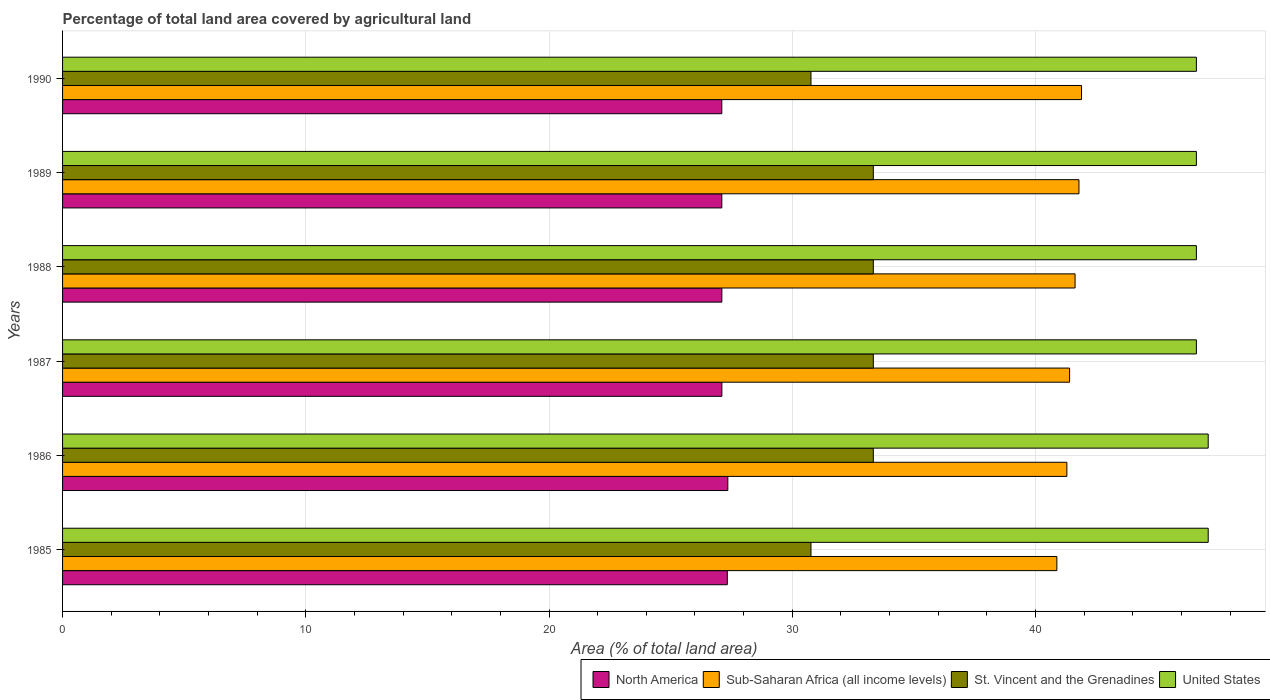How many different coloured bars are there?
Ensure brevity in your answer.  4. Are the number of bars per tick equal to the number of legend labels?
Offer a terse response. Yes. How many bars are there on the 4th tick from the top?
Keep it short and to the point. 4. How many bars are there on the 5th tick from the bottom?
Keep it short and to the point. 4. What is the percentage of agricultural land in United States in 1989?
Your answer should be very brief. 46.62. Across all years, what is the maximum percentage of agricultural land in St. Vincent and the Grenadines?
Provide a succinct answer. 33.33. Across all years, what is the minimum percentage of agricultural land in St. Vincent and the Grenadines?
Your response must be concise. 30.77. In which year was the percentage of agricultural land in North America maximum?
Make the answer very short. 1986. What is the total percentage of agricultural land in United States in the graph?
Your response must be concise. 280.66. What is the difference between the percentage of agricultural land in St. Vincent and the Grenadines in 1985 and that in 1987?
Your answer should be compact. -2.56. What is the difference between the percentage of agricultural land in United States in 1990 and the percentage of agricultural land in North America in 1987?
Your response must be concise. 19.51. What is the average percentage of agricultural land in United States per year?
Ensure brevity in your answer.  46.78. In the year 1989, what is the difference between the percentage of agricultural land in St. Vincent and the Grenadines and percentage of agricultural land in United States?
Keep it short and to the point. -13.28. What is the ratio of the percentage of agricultural land in North America in 1985 to that in 1986?
Your answer should be compact. 1. Is the difference between the percentage of agricultural land in St. Vincent and the Grenadines in 1988 and 1989 greater than the difference between the percentage of agricultural land in United States in 1988 and 1989?
Offer a very short reply. No. What is the difference between the highest and the second highest percentage of agricultural land in St. Vincent and the Grenadines?
Offer a terse response. 0. What is the difference between the highest and the lowest percentage of agricultural land in Sub-Saharan Africa (all income levels)?
Offer a very short reply. 1.01. Is the sum of the percentage of agricultural land in North America in 1989 and 1990 greater than the maximum percentage of agricultural land in St. Vincent and the Grenadines across all years?
Make the answer very short. Yes. What does the 1st bar from the top in 1988 represents?
Your answer should be compact. United States. Is it the case that in every year, the sum of the percentage of agricultural land in Sub-Saharan Africa (all income levels) and percentage of agricultural land in North America is greater than the percentage of agricultural land in St. Vincent and the Grenadines?
Ensure brevity in your answer.  Yes. How many bars are there?
Keep it short and to the point. 24. Are all the bars in the graph horizontal?
Keep it short and to the point. Yes. How many years are there in the graph?
Your answer should be compact. 6. What is the difference between two consecutive major ticks on the X-axis?
Offer a terse response. 10. Are the values on the major ticks of X-axis written in scientific E-notation?
Your response must be concise. No. How many legend labels are there?
Ensure brevity in your answer.  4. How are the legend labels stacked?
Your answer should be very brief. Horizontal. What is the title of the graph?
Keep it short and to the point. Percentage of total land area covered by agricultural land. Does "Maldives" appear as one of the legend labels in the graph?
Offer a very short reply. No. What is the label or title of the X-axis?
Make the answer very short. Area (% of total land area). What is the label or title of the Y-axis?
Your answer should be compact. Years. What is the Area (% of total land area) in North America in 1985?
Your answer should be very brief. 27.33. What is the Area (% of total land area) in Sub-Saharan Africa (all income levels) in 1985?
Offer a very short reply. 40.88. What is the Area (% of total land area) of St. Vincent and the Grenadines in 1985?
Offer a very short reply. 30.77. What is the Area (% of total land area) in United States in 1985?
Provide a short and direct response. 47.1. What is the Area (% of total land area) of North America in 1986?
Offer a very short reply. 27.35. What is the Area (% of total land area) in Sub-Saharan Africa (all income levels) in 1986?
Your response must be concise. 41.29. What is the Area (% of total land area) of St. Vincent and the Grenadines in 1986?
Your response must be concise. 33.33. What is the Area (% of total land area) of United States in 1986?
Your answer should be compact. 47.1. What is the Area (% of total land area) in North America in 1987?
Your answer should be compact. 27.11. What is the Area (% of total land area) in Sub-Saharan Africa (all income levels) in 1987?
Offer a very short reply. 41.4. What is the Area (% of total land area) of St. Vincent and the Grenadines in 1987?
Provide a succinct answer. 33.33. What is the Area (% of total land area) in United States in 1987?
Provide a succinct answer. 46.62. What is the Area (% of total land area) in North America in 1988?
Your answer should be very brief. 27.11. What is the Area (% of total land area) in Sub-Saharan Africa (all income levels) in 1988?
Your answer should be compact. 41.63. What is the Area (% of total land area) in St. Vincent and the Grenadines in 1988?
Ensure brevity in your answer.  33.33. What is the Area (% of total land area) of United States in 1988?
Keep it short and to the point. 46.62. What is the Area (% of total land area) in North America in 1989?
Your response must be concise. 27.1. What is the Area (% of total land area) of Sub-Saharan Africa (all income levels) in 1989?
Provide a succinct answer. 41.79. What is the Area (% of total land area) in St. Vincent and the Grenadines in 1989?
Give a very brief answer. 33.33. What is the Area (% of total land area) in United States in 1989?
Offer a terse response. 46.62. What is the Area (% of total land area) of North America in 1990?
Ensure brevity in your answer.  27.1. What is the Area (% of total land area) of Sub-Saharan Africa (all income levels) in 1990?
Keep it short and to the point. 41.89. What is the Area (% of total land area) of St. Vincent and the Grenadines in 1990?
Give a very brief answer. 30.77. What is the Area (% of total land area) in United States in 1990?
Offer a terse response. 46.62. Across all years, what is the maximum Area (% of total land area) of North America?
Make the answer very short. 27.35. Across all years, what is the maximum Area (% of total land area) in Sub-Saharan Africa (all income levels)?
Give a very brief answer. 41.89. Across all years, what is the maximum Area (% of total land area) in St. Vincent and the Grenadines?
Provide a short and direct response. 33.33. Across all years, what is the maximum Area (% of total land area) of United States?
Offer a terse response. 47.1. Across all years, what is the minimum Area (% of total land area) of North America?
Your answer should be very brief. 27.1. Across all years, what is the minimum Area (% of total land area) of Sub-Saharan Africa (all income levels)?
Keep it short and to the point. 40.88. Across all years, what is the minimum Area (% of total land area) of St. Vincent and the Grenadines?
Your answer should be compact. 30.77. Across all years, what is the minimum Area (% of total land area) of United States?
Your answer should be very brief. 46.62. What is the total Area (% of total land area) in North America in the graph?
Your answer should be very brief. 163.1. What is the total Area (% of total land area) in Sub-Saharan Africa (all income levels) in the graph?
Give a very brief answer. 248.88. What is the total Area (% of total land area) of St. Vincent and the Grenadines in the graph?
Keep it short and to the point. 194.87. What is the total Area (% of total land area) of United States in the graph?
Keep it short and to the point. 280.66. What is the difference between the Area (% of total land area) in North America in 1985 and that in 1986?
Your answer should be very brief. -0.02. What is the difference between the Area (% of total land area) in Sub-Saharan Africa (all income levels) in 1985 and that in 1986?
Your answer should be compact. -0.41. What is the difference between the Area (% of total land area) of St. Vincent and the Grenadines in 1985 and that in 1986?
Offer a very short reply. -2.56. What is the difference between the Area (% of total land area) of North America in 1985 and that in 1987?
Offer a terse response. 0.22. What is the difference between the Area (% of total land area) of Sub-Saharan Africa (all income levels) in 1985 and that in 1987?
Your answer should be very brief. -0.52. What is the difference between the Area (% of total land area) of St. Vincent and the Grenadines in 1985 and that in 1987?
Make the answer very short. -2.56. What is the difference between the Area (% of total land area) in United States in 1985 and that in 1987?
Provide a short and direct response. 0.49. What is the difference between the Area (% of total land area) of North America in 1985 and that in 1988?
Your answer should be very brief. 0.22. What is the difference between the Area (% of total land area) in Sub-Saharan Africa (all income levels) in 1985 and that in 1988?
Provide a succinct answer. -0.75. What is the difference between the Area (% of total land area) of St. Vincent and the Grenadines in 1985 and that in 1988?
Ensure brevity in your answer.  -2.56. What is the difference between the Area (% of total land area) of United States in 1985 and that in 1988?
Offer a terse response. 0.49. What is the difference between the Area (% of total land area) in North America in 1985 and that in 1989?
Your response must be concise. 0.23. What is the difference between the Area (% of total land area) of Sub-Saharan Africa (all income levels) in 1985 and that in 1989?
Offer a terse response. -0.91. What is the difference between the Area (% of total land area) in St. Vincent and the Grenadines in 1985 and that in 1989?
Offer a very short reply. -2.56. What is the difference between the Area (% of total land area) in United States in 1985 and that in 1989?
Make the answer very short. 0.49. What is the difference between the Area (% of total land area) in North America in 1985 and that in 1990?
Ensure brevity in your answer.  0.23. What is the difference between the Area (% of total land area) of Sub-Saharan Africa (all income levels) in 1985 and that in 1990?
Ensure brevity in your answer.  -1.01. What is the difference between the Area (% of total land area) of St. Vincent and the Grenadines in 1985 and that in 1990?
Offer a very short reply. 0. What is the difference between the Area (% of total land area) of United States in 1985 and that in 1990?
Your response must be concise. 0.49. What is the difference between the Area (% of total land area) of North America in 1986 and that in 1987?
Your answer should be very brief. 0.24. What is the difference between the Area (% of total land area) of Sub-Saharan Africa (all income levels) in 1986 and that in 1987?
Provide a succinct answer. -0.11. What is the difference between the Area (% of total land area) in United States in 1986 and that in 1987?
Give a very brief answer. 0.49. What is the difference between the Area (% of total land area) of North America in 1986 and that in 1988?
Make the answer very short. 0.25. What is the difference between the Area (% of total land area) of Sub-Saharan Africa (all income levels) in 1986 and that in 1988?
Ensure brevity in your answer.  -0.34. What is the difference between the Area (% of total land area) in St. Vincent and the Grenadines in 1986 and that in 1988?
Your answer should be compact. 0. What is the difference between the Area (% of total land area) of United States in 1986 and that in 1988?
Keep it short and to the point. 0.49. What is the difference between the Area (% of total land area) in North America in 1986 and that in 1989?
Offer a terse response. 0.25. What is the difference between the Area (% of total land area) in Sub-Saharan Africa (all income levels) in 1986 and that in 1989?
Provide a short and direct response. -0.5. What is the difference between the Area (% of total land area) of United States in 1986 and that in 1989?
Provide a succinct answer. 0.49. What is the difference between the Area (% of total land area) of North America in 1986 and that in 1990?
Offer a terse response. 0.25. What is the difference between the Area (% of total land area) in Sub-Saharan Africa (all income levels) in 1986 and that in 1990?
Offer a very short reply. -0.6. What is the difference between the Area (% of total land area) of St. Vincent and the Grenadines in 1986 and that in 1990?
Ensure brevity in your answer.  2.56. What is the difference between the Area (% of total land area) in United States in 1986 and that in 1990?
Make the answer very short. 0.49. What is the difference between the Area (% of total land area) of North America in 1987 and that in 1988?
Your response must be concise. 0. What is the difference between the Area (% of total land area) in Sub-Saharan Africa (all income levels) in 1987 and that in 1988?
Provide a succinct answer. -0.22. What is the difference between the Area (% of total land area) of St. Vincent and the Grenadines in 1987 and that in 1988?
Give a very brief answer. 0. What is the difference between the Area (% of total land area) in United States in 1987 and that in 1988?
Your answer should be very brief. 0. What is the difference between the Area (% of total land area) of North America in 1987 and that in 1989?
Give a very brief answer. 0. What is the difference between the Area (% of total land area) of Sub-Saharan Africa (all income levels) in 1987 and that in 1989?
Your answer should be compact. -0.38. What is the difference between the Area (% of total land area) in St. Vincent and the Grenadines in 1987 and that in 1989?
Ensure brevity in your answer.  0. What is the difference between the Area (% of total land area) in North America in 1987 and that in 1990?
Give a very brief answer. 0. What is the difference between the Area (% of total land area) of Sub-Saharan Africa (all income levels) in 1987 and that in 1990?
Ensure brevity in your answer.  -0.49. What is the difference between the Area (% of total land area) in St. Vincent and the Grenadines in 1987 and that in 1990?
Make the answer very short. 2.56. What is the difference between the Area (% of total land area) in United States in 1987 and that in 1990?
Your response must be concise. 0. What is the difference between the Area (% of total land area) in North America in 1988 and that in 1989?
Your response must be concise. 0. What is the difference between the Area (% of total land area) of Sub-Saharan Africa (all income levels) in 1988 and that in 1989?
Keep it short and to the point. -0.16. What is the difference between the Area (% of total land area) in St. Vincent and the Grenadines in 1988 and that in 1989?
Keep it short and to the point. 0. What is the difference between the Area (% of total land area) of United States in 1988 and that in 1989?
Provide a short and direct response. 0. What is the difference between the Area (% of total land area) in North America in 1988 and that in 1990?
Ensure brevity in your answer.  0. What is the difference between the Area (% of total land area) of Sub-Saharan Africa (all income levels) in 1988 and that in 1990?
Give a very brief answer. -0.27. What is the difference between the Area (% of total land area) of St. Vincent and the Grenadines in 1988 and that in 1990?
Give a very brief answer. 2.56. What is the difference between the Area (% of total land area) in United States in 1988 and that in 1990?
Your answer should be very brief. 0. What is the difference between the Area (% of total land area) of North America in 1989 and that in 1990?
Provide a succinct answer. 0. What is the difference between the Area (% of total land area) of Sub-Saharan Africa (all income levels) in 1989 and that in 1990?
Ensure brevity in your answer.  -0.11. What is the difference between the Area (% of total land area) in St. Vincent and the Grenadines in 1989 and that in 1990?
Give a very brief answer. 2.56. What is the difference between the Area (% of total land area) in United States in 1989 and that in 1990?
Provide a short and direct response. 0. What is the difference between the Area (% of total land area) of North America in 1985 and the Area (% of total land area) of Sub-Saharan Africa (all income levels) in 1986?
Provide a succinct answer. -13.96. What is the difference between the Area (% of total land area) of North America in 1985 and the Area (% of total land area) of St. Vincent and the Grenadines in 1986?
Offer a very short reply. -6. What is the difference between the Area (% of total land area) of North America in 1985 and the Area (% of total land area) of United States in 1986?
Your answer should be compact. -19.77. What is the difference between the Area (% of total land area) of Sub-Saharan Africa (all income levels) in 1985 and the Area (% of total land area) of St. Vincent and the Grenadines in 1986?
Ensure brevity in your answer.  7.55. What is the difference between the Area (% of total land area) in Sub-Saharan Africa (all income levels) in 1985 and the Area (% of total land area) in United States in 1986?
Your response must be concise. -6.22. What is the difference between the Area (% of total land area) in St. Vincent and the Grenadines in 1985 and the Area (% of total land area) in United States in 1986?
Your response must be concise. -16.33. What is the difference between the Area (% of total land area) in North America in 1985 and the Area (% of total land area) in Sub-Saharan Africa (all income levels) in 1987?
Give a very brief answer. -14.07. What is the difference between the Area (% of total land area) in North America in 1985 and the Area (% of total land area) in St. Vincent and the Grenadines in 1987?
Keep it short and to the point. -6. What is the difference between the Area (% of total land area) in North America in 1985 and the Area (% of total land area) in United States in 1987?
Your answer should be compact. -19.29. What is the difference between the Area (% of total land area) in Sub-Saharan Africa (all income levels) in 1985 and the Area (% of total land area) in St. Vincent and the Grenadines in 1987?
Provide a succinct answer. 7.55. What is the difference between the Area (% of total land area) in Sub-Saharan Africa (all income levels) in 1985 and the Area (% of total land area) in United States in 1987?
Your answer should be very brief. -5.74. What is the difference between the Area (% of total land area) in St. Vincent and the Grenadines in 1985 and the Area (% of total land area) in United States in 1987?
Give a very brief answer. -15.85. What is the difference between the Area (% of total land area) of North America in 1985 and the Area (% of total land area) of Sub-Saharan Africa (all income levels) in 1988?
Your response must be concise. -14.3. What is the difference between the Area (% of total land area) of North America in 1985 and the Area (% of total land area) of St. Vincent and the Grenadines in 1988?
Ensure brevity in your answer.  -6. What is the difference between the Area (% of total land area) in North America in 1985 and the Area (% of total land area) in United States in 1988?
Your answer should be compact. -19.29. What is the difference between the Area (% of total land area) of Sub-Saharan Africa (all income levels) in 1985 and the Area (% of total land area) of St. Vincent and the Grenadines in 1988?
Your answer should be very brief. 7.55. What is the difference between the Area (% of total land area) in Sub-Saharan Africa (all income levels) in 1985 and the Area (% of total land area) in United States in 1988?
Provide a succinct answer. -5.74. What is the difference between the Area (% of total land area) of St. Vincent and the Grenadines in 1985 and the Area (% of total land area) of United States in 1988?
Keep it short and to the point. -15.85. What is the difference between the Area (% of total land area) of North America in 1985 and the Area (% of total land area) of Sub-Saharan Africa (all income levels) in 1989?
Keep it short and to the point. -14.46. What is the difference between the Area (% of total land area) of North America in 1985 and the Area (% of total land area) of St. Vincent and the Grenadines in 1989?
Keep it short and to the point. -6. What is the difference between the Area (% of total land area) of North America in 1985 and the Area (% of total land area) of United States in 1989?
Your answer should be very brief. -19.29. What is the difference between the Area (% of total land area) in Sub-Saharan Africa (all income levels) in 1985 and the Area (% of total land area) in St. Vincent and the Grenadines in 1989?
Give a very brief answer. 7.55. What is the difference between the Area (% of total land area) in Sub-Saharan Africa (all income levels) in 1985 and the Area (% of total land area) in United States in 1989?
Your answer should be very brief. -5.74. What is the difference between the Area (% of total land area) of St. Vincent and the Grenadines in 1985 and the Area (% of total land area) of United States in 1989?
Your response must be concise. -15.85. What is the difference between the Area (% of total land area) in North America in 1985 and the Area (% of total land area) in Sub-Saharan Africa (all income levels) in 1990?
Your answer should be compact. -14.56. What is the difference between the Area (% of total land area) in North America in 1985 and the Area (% of total land area) in St. Vincent and the Grenadines in 1990?
Offer a very short reply. -3.44. What is the difference between the Area (% of total land area) of North America in 1985 and the Area (% of total land area) of United States in 1990?
Offer a very short reply. -19.29. What is the difference between the Area (% of total land area) in Sub-Saharan Africa (all income levels) in 1985 and the Area (% of total land area) in St. Vincent and the Grenadines in 1990?
Your answer should be very brief. 10.11. What is the difference between the Area (% of total land area) in Sub-Saharan Africa (all income levels) in 1985 and the Area (% of total land area) in United States in 1990?
Your answer should be compact. -5.74. What is the difference between the Area (% of total land area) of St. Vincent and the Grenadines in 1985 and the Area (% of total land area) of United States in 1990?
Offer a very short reply. -15.85. What is the difference between the Area (% of total land area) of North America in 1986 and the Area (% of total land area) of Sub-Saharan Africa (all income levels) in 1987?
Offer a very short reply. -14.05. What is the difference between the Area (% of total land area) in North America in 1986 and the Area (% of total land area) in St. Vincent and the Grenadines in 1987?
Your answer should be very brief. -5.98. What is the difference between the Area (% of total land area) in North America in 1986 and the Area (% of total land area) in United States in 1987?
Your answer should be compact. -19.26. What is the difference between the Area (% of total land area) in Sub-Saharan Africa (all income levels) in 1986 and the Area (% of total land area) in St. Vincent and the Grenadines in 1987?
Give a very brief answer. 7.96. What is the difference between the Area (% of total land area) in Sub-Saharan Africa (all income levels) in 1986 and the Area (% of total land area) in United States in 1987?
Make the answer very short. -5.32. What is the difference between the Area (% of total land area) of St. Vincent and the Grenadines in 1986 and the Area (% of total land area) of United States in 1987?
Ensure brevity in your answer.  -13.28. What is the difference between the Area (% of total land area) in North America in 1986 and the Area (% of total land area) in Sub-Saharan Africa (all income levels) in 1988?
Keep it short and to the point. -14.28. What is the difference between the Area (% of total land area) in North America in 1986 and the Area (% of total land area) in St. Vincent and the Grenadines in 1988?
Give a very brief answer. -5.98. What is the difference between the Area (% of total land area) of North America in 1986 and the Area (% of total land area) of United States in 1988?
Your answer should be very brief. -19.26. What is the difference between the Area (% of total land area) in Sub-Saharan Africa (all income levels) in 1986 and the Area (% of total land area) in St. Vincent and the Grenadines in 1988?
Offer a very short reply. 7.96. What is the difference between the Area (% of total land area) in Sub-Saharan Africa (all income levels) in 1986 and the Area (% of total land area) in United States in 1988?
Your answer should be very brief. -5.32. What is the difference between the Area (% of total land area) in St. Vincent and the Grenadines in 1986 and the Area (% of total land area) in United States in 1988?
Keep it short and to the point. -13.28. What is the difference between the Area (% of total land area) in North America in 1986 and the Area (% of total land area) in Sub-Saharan Africa (all income levels) in 1989?
Your response must be concise. -14.44. What is the difference between the Area (% of total land area) of North America in 1986 and the Area (% of total land area) of St. Vincent and the Grenadines in 1989?
Provide a succinct answer. -5.98. What is the difference between the Area (% of total land area) in North America in 1986 and the Area (% of total land area) in United States in 1989?
Ensure brevity in your answer.  -19.26. What is the difference between the Area (% of total land area) of Sub-Saharan Africa (all income levels) in 1986 and the Area (% of total land area) of St. Vincent and the Grenadines in 1989?
Your answer should be compact. 7.96. What is the difference between the Area (% of total land area) in Sub-Saharan Africa (all income levels) in 1986 and the Area (% of total land area) in United States in 1989?
Your answer should be compact. -5.32. What is the difference between the Area (% of total land area) in St. Vincent and the Grenadines in 1986 and the Area (% of total land area) in United States in 1989?
Offer a terse response. -13.28. What is the difference between the Area (% of total land area) of North America in 1986 and the Area (% of total land area) of Sub-Saharan Africa (all income levels) in 1990?
Provide a short and direct response. -14.54. What is the difference between the Area (% of total land area) in North America in 1986 and the Area (% of total land area) in St. Vincent and the Grenadines in 1990?
Your answer should be compact. -3.42. What is the difference between the Area (% of total land area) in North America in 1986 and the Area (% of total land area) in United States in 1990?
Your answer should be compact. -19.26. What is the difference between the Area (% of total land area) of Sub-Saharan Africa (all income levels) in 1986 and the Area (% of total land area) of St. Vincent and the Grenadines in 1990?
Make the answer very short. 10.52. What is the difference between the Area (% of total land area) in Sub-Saharan Africa (all income levels) in 1986 and the Area (% of total land area) in United States in 1990?
Your answer should be compact. -5.32. What is the difference between the Area (% of total land area) in St. Vincent and the Grenadines in 1986 and the Area (% of total land area) in United States in 1990?
Provide a succinct answer. -13.28. What is the difference between the Area (% of total land area) of North America in 1987 and the Area (% of total land area) of Sub-Saharan Africa (all income levels) in 1988?
Offer a very short reply. -14.52. What is the difference between the Area (% of total land area) of North America in 1987 and the Area (% of total land area) of St. Vincent and the Grenadines in 1988?
Provide a short and direct response. -6.23. What is the difference between the Area (% of total land area) in North America in 1987 and the Area (% of total land area) in United States in 1988?
Your response must be concise. -19.51. What is the difference between the Area (% of total land area) in Sub-Saharan Africa (all income levels) in 1987 and the Area (% of total land area) in St. Vincent and the Grenadines in 1988?
Make the answer very short. 8.07. What is the difference between the Area (% of total land area) in Sub-Saharan Africa (all income levels) in 1987 and the Area (% of total land area) in United States in 1988?
Offer a terse response. -5.21. What is the difference between the Area (% of total land area) of St. Vincent and the Grenadines in 1987 and the Area (% of total land area) of United States in 1988?
Offer a terse response. -13.28. What is the difference between the Area (% of total land area) of North America in 1987 and the Area (% of total land area) of Sub-Saharan Africa (all income levels) in 1989?
Keep it short and to the point. -14.68. What is the difference between the Area (% of total land area) of North America in 1987 and the Area (% of total land area) of St. Vincent and the Grenadines in 1989?
Your answer should be compact. -6.23. What is the difference between the Area (% of total land area) in North America in 1987 and the Area (% of total land area) in United States in 1989?
Ensure brevity in your answer.  -19.51. What is the difference between the Area (% of total land area) of Sub-Saharan Africa (all income levels) in 1987 and the Area (% of total land area) of St. Vincent and the Grenadines in 1989?
Ensure brevity in your answer.  8.07. What is the difference between the Area (% of total land area) of Sub-Saharan Africa (all income levels) in 1987 and the Area (% of total land area) of United States in 1989?
Make the answer very short. -5.21. What is the difference between the Area (% of total land area) in St. Vincent and the Grenadines in 1987 and the Area (% of total land area) in United States in 1989?
Provide a short and direct response. -13.28. What is the difference between the Area (% of total land area) in North America in 1987 and the Area (% of total land area) in Sub-Saharan Africa (all income levels) in 1990?
Make the answer very short. -14.79. What is the difference between the Area (% of total land area) in North America in 1987 and the Area (% of total land area) in St. Vincent and the Grenadines in 1990?
Your answer should be compact. -3.66. What is the difference between the Area (% of total land area) of North America in 1987 and the Area (% of total land area) of United States in 1990?
Your response must be concise. -19.51. What is the difference between the Area (% of total land area) of Sub-Saharan Africa (all income levels) in 1987 and the Area (% of total land area) of St. Vincent and the Grenadines in 1990?
Offer a very short reply. 10.63. What is the difference between the Area (% of total land area) of Sub-Saharan Africa (all income levels) in 1987 and the Area (% of total land area) of United States in 1990?
Make the answer very short. -5.21. What is the difference between the Area (% of total land area) in St. Vincent and the Grenadines in 1987 and the Area (% of total land area) in United States in 1990?
Your answer should be very brief. -13.28. What is the difference between the Area (% of total land area) in North America in 1988 and the Area (% of total land area) in Sub-Saharan Africa (all income levels) in 1989?
Offer a very short reply. -14.68. What is the difference between the Area (% of total land area) of North America in 1988 and the Area (% of total land area) of St. Vincent and the Grenadines in 1989?
Keep it short and to the point. -6.23. What is the difference between the Area (% of total land area) of North America in 1988 and the Area (% of total land area) of United States in 1989?
Keep it short and to the point. -19.51. What is the difference between the Area (% of total land area) of Sub-Saharan Africa (all income levels) in 1988 and the Area (% of total land area) of St. Vincent and the Grenadines in 1989?
Give a very brief answer. 8.29. What is the difference between the Area (% of total land area) in Sub-Saharan Africa (all income levels) in 1988 and the Area (% of total land area) in United States in 1989?
Your answer should be very brief. -4.99. What is the difference between the Area (% of total land area) of St. Vincent and the Grenadines in 1988 and the Area (% of total land area) of United States in 1989?
Your answer should be very brief. -13.28. What is the difference between the Area (% of total land area) in North America in 1988 and the Area (% of total land area) in Sub-Saharan Africa (all income levels) in 1990?
Offer a terse response. -14.79. What is the difference between the Area (% of total land area) of North America in 1988 and the Area (% of total land area) of St. Vincent and the Grenadines in 1990?
Keep it short and to the point. -3.66. What is the difference between the Area (% of total land area) of North America in 1988 and the Area (% of total land area) of United States in 1990?
Your answer should be very brief. -19.51. What is the difference between the Area (% of total land area) in Sub-Saharan Africa (all income levels) in 1988 and the Area (% of total land area) in St. Vincent and the Grenadines in 1990?
Your answer should be compact. 10.86. What is the difference between the Area (% of total land area) of Sub-Saharan Africa (all income levels) in 1988 and the Area (% of total land area) of United States in 1990?
Keep it short and to the point. -4.99. What is the difference between the Area (% of total land area) of St. Vincent and the Grenadines in 1988 and the Area (% of total land area) of United States in 1990?
Offer a terse response. -13.28. What is the difference between the Area (% of total land area) in North America in 1989 and the Area (% of total land area) in Sub-Saharan Africa (all income levels) in 1990?
Offer a very short reply. -14.79. What is the difference between the Area (% of total land area) of North America in 1989 and the Area (% of total land area) of St. Vincent and the Grenadines in 1990?
Provide a succinct answer. -3.66. What is the difference between the Area (% of total land area) in North America in 1989 and the Area (% of total land area) in United States in 1990?
Provide a succinct answer. -19.51. What is the difference between the Area (% of total land area) of Sub-Saharan Africa (all income levels) in 1989 and the Area (% of total land area) of St. Vincent and the Grenadines in 1990?
Offer a very short reply. 11.02. What is the difference between the Area (% of total land area) of Sub-Saharan Africa (all income levels) in 1989 and the Area (% of total land area) of United States in 1990?
Give a very brief answer. -4.83. What is the difference between the Area (% of total land area) in St. Vincent and the Grenadines in 1989 and the Area (% of total land area) in United States in 1990?
Make the answer very short. -13.28. What is the average Area (% of total land area) of North America per year?
Your answer should be very brief. 27.18. What is the average Area (% of total land area) of Sub-Saharan Africa (all income levels) per year?
Ensure brevity in your answer.  41.48. What is the average Area (% of total land area) of St. Vincent and the Grenadines per year?
Make the answer very short. 32.48. What is the average Area (% of total land area) in United States per year?
Your answer should be compact. 46.78. In the year 1985, what is the difference between the Area (% of total land area) in North America and Area (% of total land area) in Sub-Saharan Africa (all income levels)?
Offer a very short reply. -13.55. In the year 1985, what is the difference between the Area (% of total land area) in North America and Area (% of total land area) in St. Vincent and the Grenadines?
Offer a very short reply. -3.44. In the year 1985, what is the difference between the Area (% of total land area) in North America and Area (% of total land area) in United States?
Your response must be concise. -19.77. In the year 1985, what is the difference between the Area (% of total land area) in Sub-Saharan Africa (all income levels) and Area (% of total land area) in St. Vincent and the Grenadines?
Ensure brevity in your answer.  10.11. In the year 1985, what is the difference between the Area (% of total land area) in Sub-Saharan Africa (all income levels) and Area (% of total land area) in United States?
Provide a succinct answer. -6.22. In the year 1985, what is the difference between the Area (% of total land area) of St. Vincent and the Grenadines and Area (% of total land area) of United States?
Give a very brief answer. -16.33. In the year 1986, what is the difference between the Area (% of total land area) in North America and Area (% of total land area) in Sub-Saharan Africa (all income levels)?
Provide a succinct answer. -13.94. In the year 1986, what is the difference between the Area (% of total land area) of North America and Area (% of total land area) of St. Vincent and the Grenadines?
Offer a terse response. -5.98. In the year 1986, what is the difference between the Area (% of total land area) in North America and Area (% of total land area) in United States?
Your response must be concise. -19.75. In the year 1986, what is the difference between the Area (% of total land area) in Sub-Saharan Africa (all income levels) and Area (% of total land area) in St. Vincent and the Grenadines?
Keep it short and to the point. 7.96. In the year 1986, what is the difference between the Area (% of total land area) in Sub-Saharan Africa (all income levels) and Area (% of total land area) in United States?
Your answer should be very brief. -5.81. In the year 1986, what is the difference between the Area (% of total land area) of St. Vincent and the Grenadines and Area (% of total land area) of United States?
Your answer should be compact. -13.77. In the year 1987, what is the difference between the Area (% of total land area) of North America and Area (% of total land area) of Sub-Saharan Africa (all income levels)?
Provide a succinct answer. -14.3. In the year 1987, what is the difference between the Area (% of total land area) of North America and Area (% of total land area) of St. Vincent and the Grenadines?
Ensure brevity in your answer.  -6.23. In the year 1987, what is the difference between the Area (% of total land area) of North America and Area (% of total land area) of United States?
Provide a succinct answer. -19.51. In the year 1987, what is the difference between the Area (% of total land area) of Sub-Saharan Africa (all income levels) and Area (% of total land area) of St. Vincent and the Grenadines?
Keep it short and to the point. 8.07. In the year 1987, what is the difference between the Area (% of total land area) of Sub-Saharan Africa (all income levels) and Area (% of total land area) of United States?
Offer a terse response. -5.21. In the year 1987, what is the difference between the Area (% of total land area) in St. Vincent and the Grenadines and Area (% of total land area) in United States?
Give a very brief answer. -13.28. In the year 1988, what is the difference between the Area (% of total land area) of North America and Area (% of total land area) of Sub-Saharan Africa (all income levels)?
Keep it short and to the point. -14.52. In the year 1988, what is the difference between the Area (% of total land area) of North America and Area (% of total land area) of St. Vincent and the Grenadines?
Your answer should be compact. -6.23. In the year 1988, what is the difference between the Area (% of total land area) in North America and Area (% of total land area) in United States?
Provide a succinct answer. -19.51. In the year 1988, what is the difference between the Area (% of total land area) of Sub-Saharan Africa (all income levels) and Area (% of total land area) of St. Vincent and the Grenadines?
Provide a short and direct response. 8.29. In the year 1988, what is the difference between the Area (% of total land area) in Sub-Saharan Africa (all income levels) and Area (% of total land area) in United States?
Provide a short and direct response. -4.99. In the year 1988, what is the difference between the Area (% of total land area) of St. Vincent and the Grenadines and Area (% of total land area) of United States?
Provide a short and direct response. -13.28. In the year 1989, what is the difference between the Area (% of total land area) of North America and Area (% of total land area) of Sub-Saharan Africa (all income levels)?
Provide a short and direct response. -14.68. In the year 1989, what is the difference between the Area (% of total land area) of North America and Area (% of total land area) of St. Vincent and the Grenadines?
Your answer should be very brief. -6.23. In the year 1989, what is the difference between the Area (% of total land area) in North America and Area (% of total land area) in United States?
Offer a very short reply. -19.51. In the year 1989, what is the difference between the Area (% of total land area) in Sub-Saharan Africa (all income levels) and Area (% of total land area) in St. Vincent and the Grenadines?
Provide a succinct answer. 8.45. In the year 1989, what is the difference between the Area (% of total land area) of Sub-Saharan Africa (all income levels) and Area (% of total land area) of United States?
Offer a terse response. -4.83. In the year 1989, what is the difference between the Area (% of total land area) in St. Vincent and the Grenadines and Area (% of total land area) in United States?
Ensure brevity in your answer.  -13.28. In the year 1990, what is the difference between the Area (% of total land area) of North America and Area (% of total land area) of Sub-Saharan Africa (all income levels)?
Offer a very short reply. -14.79. In the year 1990, what is the difference between the Area (% of total land area) of North America and Area (% of total land area) of St. Vincent and the Grenadines?
Your answer should be very brief. -3.67. In the year 1990, what is the difference between the Area (% of total land area) in North America and Area (% of total land area) in United States?
Make the answer very short. -19.51. In the year 1990, what is the difference between the Area (% of total land area) of Sub-Saharan Africa (all income levels) and Area (% of total land area) of St. Vincent and the Grenadines?
Provide a short and direct response. 11.12. In the year 1990, what is the difference between the Area (% of total land area) of Sub-Saharan Africa (all income levels) and Area (% of total land area) of United States?
Ensure brevity in your answer.  -4.72. In the year 1990, what is the difference between the Area (% of total land area) of St. Vincent and the Grenadines and Area (% of total land area) of United States?
Ensure brevity in your answer.  -15.85. What is the ratio of the Area (% of total land area) of North America in 1985 to that in 1986?
Give a very brief answer. 1. What is the ratio of the Area (% of total land area) in Sub-Saharan Africa (all income levels) in 1985 to that in 1986?
Your response must be concise. 0.99. What is the ratio of the Area (% of total land area) in St. Vincent and the Grenadines in 1985 to that in 1986?
Make the answer very short. 0.92. What is the ratio of the Area (% of total land area) in United States in 1985 to that in 1986?
Your response must be concise. 1. What is the ratio of the Area (% of total land area) in North America in 1985 to that in 1987?
Ensure brevity in your answer.  1.01. What is the ratio of the Area (% of total land area) in Sub-Saharan Africa (all income levels) in 1985 to that in 1987?
Keep it short and to the point. 0.99. What is the ratio of the Area (% of total land area) of United States in 1985 to that in 1987?
Give a very brief answer. 1.01. What is the ratio of the Area (% of total land area) of North America in 1985 to that in 1988?
Your answer should be compact. 1.01. What is the ratio of the Area (% of total land area) of Sub-Saharan Africa (all income levels) in 1985 to that in 1988?
Provide a succinct answer. 0.98. What is the ratio of the Area (% of total land area) of United States in 1985 to that in 1988?
Ensure brevity in your answer.  1.01. What is the ratio of the Area (% of total land area) in North America in 1985 to that in 1989?
Your response must be concise. 1.01. What is the ratio of the Area (% of total land area) in Sub-Saharan Africa (all income levels) in 1985 to that in 1989?
Offer a very short reply. 0.98. What is the ratio of the Area (% of total land area) of St. Vincent and the Grenadines in 1985 to that in 1989?
Your answer should be compact. 0.92. What is the ratio of the Area (% of total land area) of United States in 1985 to that in 1989?
Make the answer very short. 1.01. What is the ratio of the Area (% of total land area) of North America in 1985 to that in 1990?
Ensure brevity in your answer.  1.01. What is the ratio of the Area (% of total land area) in Sub-Saharan Africa (all income levels) in 1985 to that in 1990?
Provide a short and direct response. 0.98. What is the ratio of the Area (% of total land area) of St. Vincent and the Grenadines in 1985 to that in 1990?
Make the answer very short. 1. What is the ratio of the Area (% of total land area) of United States in 1985 to that in 1990?
Provide a succinct answer. 1.01. What is the ratio of the Area (% of total land area) in St. Vincent and the Grenadines in 1986 to that in 1987?
Your answer should be compact. 1. What is the ratio of the Area (% of total land area) in United States in 1986 to that in 1987?
Make the answer very short. 1.01. What is the ratio of the Area (% of total land area) of North America in 1986 to that in 1988?
Keep it short and to the point. 1.01. What is the ratio of the Area (% of total land area) in Sub-Saharan Africa (all income levels) in 1986 to that in 1988?
Your response must be concise. 0.99. What is the ratio of the Area (% of total land area) of St. Vincent and the Grenadines in 1986 to that in 1988?
Your answer should be very brief. 1. What is the ratio of the Area (% of total land area) of United States in 1986 to that in 1988?
Keep it short and to the point. 1.01. What is the ratio of the Area (% of total land area) of North America in 1986 to that in 1989?
Offer a terse response. 1.01. What is the ratio of the Area (% of total land area) in Sub-Saharan Africa (all income levels) in 1986 to that in 1989?
Your answer should be compact. 0.99. What is the ratio of the Area (% of total land area) of St. Vincent and the Grenadines in 1986 to that in 1989?
Provide a short and direct response. 1. What is the ratio of the Area (% of total land area) of United States in 1986 to that in 1989?
Ensure brevity in your answer.  1.01. What is the ratio of the Area (% of total land area) in North America in 1986 to that in 1990?
Keep it short and to the point. 1.01. What is the ratio of the Area (% of total land area) of Sub-Saharan Africa (all income levels) in 1986 to that in 1990?
Offer a very short reply. 0.99. What is the ratio of the Area (% of total land area) in United States in 1986 to that in 1990?
Ensure brevity in your answer.  1.01. What is the ratio of the Area (% of total land area) of St. Vincent and the Grenadines in 1987 to that in 1988?
Your answer should be compact. 1. What is the ratio of the Area (% of total land area) of United States in 1987 to that in 1988?
Offer a terse response. 1. What is the ratio of the Area (% of total land area) of North America in 1987 to that in 1989?
Your answer should be compact. 1. What is the ratio of the Area (% of total land area) of Sub-Saharan Africa (all income levels) in 1987 to that in 1989?
Provide a short and direct response. 0.99. What is the ratio of the Area (% of total land area) in St. Vincent and the Grenadines in 1987 to that in 1989?
Your answer should be very brief. 1. What is the ratio of the Area (% of total land area) of Sub-Saharan Africa (all income levels) in 1987 to that in 1990?
Ensure brevity in your answer.  0.99. What is the ratio of the Area (% of total land area) of St. Vincent and the Grenadines in 1987 to that in 1990?
Offer a very short reply. 1.08. What is the ratio of the Area (% of total land area) of United States in 1987 to that in 1990?
Keep it short and to the point. 1. What is the ratio of the Area (% of total land area) in United States in 1988 to that in 1989?
Keep it short and to the point. 1. What is the ratio of the Area (% of total land area) of St. Vincent and the Grenadines in 1988 to that in 1990?
Keep it short and to the point. 1.08. What is the ratio of the Area (% of total land area) in United States in 1988 to that in 1990?
Your response must be concise. 1. What is the ratio of the Area (% of total land area) in North America in 1989 to that in 1990?
Your answer should be compact. 1. What is the difference between the highest and the second highest Area (% of total land area) in North America?
Provide a succinct answer. 0.02. What is the difference between the highest and the second highest Area (% of total land area) of Sub-Saharan Africa (all income levels)?
Offer a very short reply. 0.11. What is the difference between the highest and the second highest Area (% of total land area) in United States?
Make the answer very short. 0. What is the difference between the highest and the lowest Area (% of total land area) of North America?
Your response must be concise. 0.25. What is the difference between the highest and the lowest Area (% of total land area) in Sub-Saharan Africa (all income levels)?
Your response must be concise. 1.01. What is the difference between the highest and the lowest Area (% of total land area) of St. Vincent and the Grenadines?
Your answer should be compact. 2.56. What is the difference between the highest and the lowest Area (% of total land area) of United States?
Give a very brief answer. 0.49. 